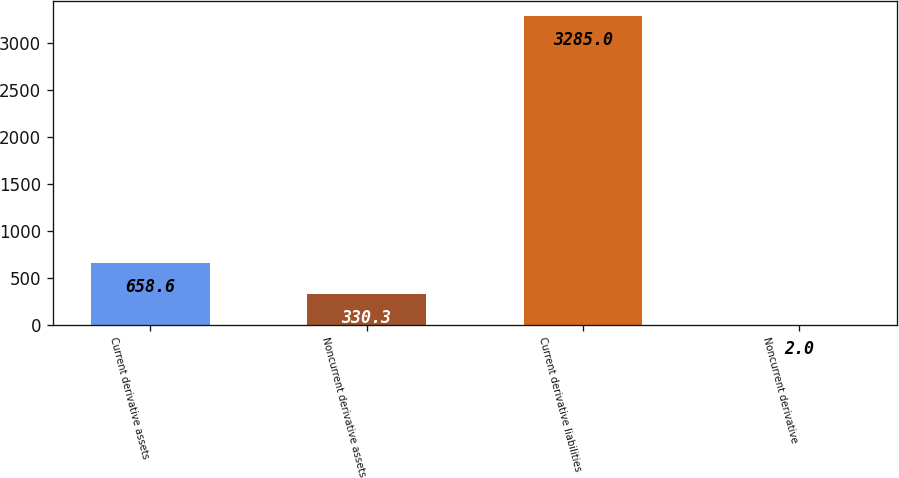Convert chart. <chart><loc_0><loc_0><loc_500><loc_500><bar_chart><fcel>Current derivative assets<fcel>Noncurrent derivative assets<fcel>Current derivative liabilities<fcel>Noncurrent derivative<nl><fcel>658.6<fcel>330.3<fcel>3285<fcel>2<nl></chart> 